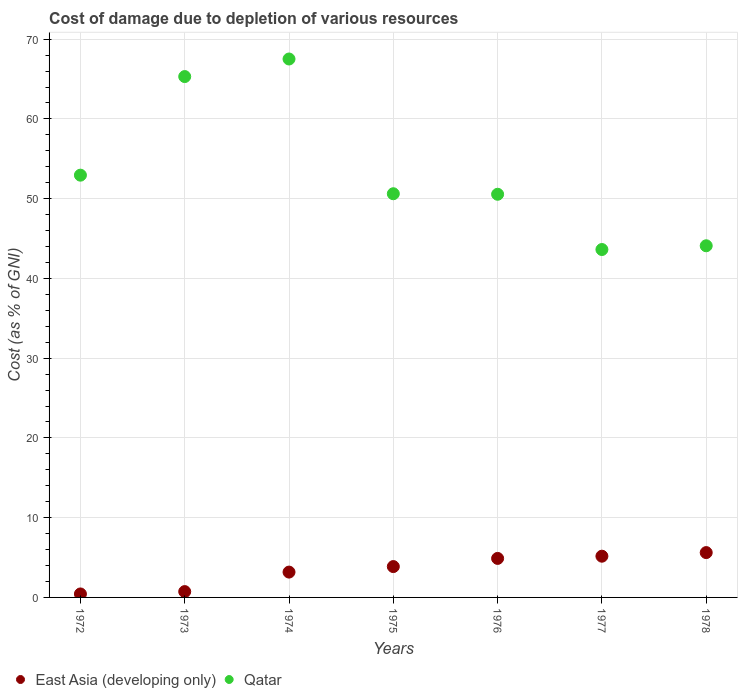How many different coloured dotlines are there?
Your answer should be very brief. 2. Is the number of dotlines equal to the number of legend labels?
Give a very brief answer. Yes. What is the cost of damage caused due to the depletion of various resources in Qatar in 1978?
Keep it short and to the point. 44.09. Across all years, what is the maximum cost of damage caused due to the depletion of various resources in East Asia (developing only)?
Provide a succinct answer. 5.62. Across all years, what is the minimum cost of damage caused due to the depletion of various resources in East Asia (developing only)?
Give a very brief answer. 0.44. In which year was the cost of damage caused due to the depletion of various resources in East Asia (developing only) maximum?
Offer a very short reply. 1978. In which year was the cost of damage caused due to the depletion of various resources in East Asia (developing only) minimum?
Give a very brief answer. 1972. What is the total cost of damage caused due to the depletion of various resources in East Asia (developing only) in the graph?
Provide a succinct answer. 23.9. What is the difference between the cost of damage caused due to the depletion of various resources in Qatar in 1974 and that in 1978?
Ensure brevity in your answer.  23.42. What is the difference between the cost of damage caused due to the depletion of various resources in Qatar in 1978 and the cost of damage caused due to the depletion of various resources in East Asia (developing only) in 1974?
Your answer should be very brief. 40.92. What is the average cost of damage caused due to the depletion of various resources in East Asia (developing only) per year?
Offer a terse response. 3.41. In the year 1974, what is the difference between the cost of damage caused due to the depletion of various resources in Qatar and cost of damage caused due to the depletion of various resources in East Asia (developing only)?
Offer a very short reply. 64.34. In how many years, is the cost of damage caused due to the depletion of various resources in Qatar greater than 48 %?
Make the answer very short. 5. What is the ratio of the cost of damage caused due to the depletion of various resources in Qatar in 1972 to that in 1978?
Provide a short and direct response. 1.2. Is the cost of damage caused due to the depletion of various resources in East Asia (developing only) in 1972 less than that in 1973?
Ensure brevity in your answer.  Yes. What is the difference between the highest and the second highest cost of damage caused due to the depletion of various resources in East Asia (developing only)?
Give a very brief answer. 0.45. What is the difference between the highest and the lowest cost of damage caused due to the depletion of various resources in East Asia (developing only)?
Make the answer very short. 5.19. In how many years, is the cost of damage caused due to the depletion of various resources in East Asia (developing only) greater than the average cost of damage caused due to the depletion of various resources in East Asia (developing only) taken over all years?
Provide a short and direct response. 4. Does the cost of damage caused due to the depletion of various resources in Qatar monotonically increase over the years?
Your answer should be compact. No. Is the cost of damage caused due to the depletion of various resources in Qatar strictly greater than the cost of damage caused due to the depletion of various resources in East Asia (developing only) over the years?
Make the answer very short. Yes. Are the values on the major ticks of Y-axis written in scientific E-notation?
Provide a short and direct response. No. Does the graph contain grids?
Give a very brief answer. Yes. How are the legend labels stacked?
Ensure brevity in your answer.  Horizontal. What is the title of the graph?
Provide a succinct answer. Cost of damage due to depletion of various resources. Does "Kyrgyz Republic" appear as one of the legend labels in the graph?
Provide a short and direct response. No. What is the label or title of the X-axis?
Your answer should be very brief. Years. What is the label or title of the Y-axis?
Provide a short and direct response. Cost (as % of GNI). What is the Cost (as % of GNI) of East Asia (developing only) in 1972?
Your answer should be very brief. 0.44. What is the Cost (as % of GNI) in Qatar in 1972?
Your response must be concise. 52.95. What is the Cost (as % of GNI) of East Asia (developing only) in 1973?
Offer a very short reply. 0.73. What is the Cost (as % of GNI) of Qatar in 1973?
Provide a succinct answer. 65.31. What is the Cost (as % of GNI) of East Asia (developing only) in 1974?
Ensure brevity in your answer.  3.18. What is the Cost (as % of GNI) in Qatar in 1974?
Your answer should be compact. 67.52. What is the Cost (as % of GNI) in East Asia (developing only) in 1975?
Ensure brevity in your answer.  3.87. What is the Cost (as % of GNI) of Qatar in 1975?
Provide a succinct answer. 50.62. What is the Cost (as % of GNI) of East Asia (developing only) in 1976?
Give a very brief answer. 4.89. What is the Cost (as % of GNI) of Qatar in 1976?
Provide a short and direct response. 50.55. What is the Cost (as % of GNI) in East Asia (developing only) in 1977?
Your response must be concise. 5.17. What is the Cost (as % of GNI) of Qatar in 1977?
Your response must be concise. 43.62. What is the Cost (as % of GNI) of East Asia (developing only) in 1978?
Offer a very short reply. 5.62. What is the Cost (as % of GNI) of Qatar in 1978?
Give a very brief answer. 44.09. Across all years, what is the maximum Cost (as % of GNI) in East Asia (developing only)?
Ensure brevity in your answer.  5.62. Across all years, what is the maximum Cost (as % of GNI) in Qatar?
Provide a short and direct response. 67.52. Across all years, what is the minimum Cost (as % of GNI) of East Asia (developing only)?
Your answer should be very brief. 0.44. Across all years, what is the minimum Cost (as % of GNI) in Qatar?
Provide a succinct answer. 43.62. What is the total Cost (as % of GNI) in East Asia (developing only) in the graph?
Provide a succinct answer. 23.9. What is the total Cost (as % of GNI) of Qatar in the graph?
Your response must be concise. 374.67. What is the difference between the Cost (as % of GNI) of East Asia (developing only) in 1972 and that in 1973?
Offer a terse response. -0.29. What is the difference between the Cost (as % of GNI) of Qatar in 1972 and that in 1973?
Ensure brevity in your answer.  -12.36. What is the difference between the Cost (as % of GNI) in East Asia (developing only) in 1972 and that in 1974?
Offer a very short reply. -2.74. What is the difference between the Cost (as % of GNI) of Qatar in 1972 and that in 1974?
Your answer should be very brief. -14.57. What is the difference between the Cost (as % of GNI) of East Asia (developing only) in 1972 and that in 1975?
Provide a succinct answer. -3.43. What is the difference between the Cost (as % of GNI) of Qatar in 1972 and that in 1975?
Ensure brevity in your answer.  2.33. What is the difference between the Cost (as % of GNI) in East Asia (developing only) in 1972 and that in 1976?
Offer a terse response. -4.46. What is the difference between the Cost (as % of GNI) of Qatar in 1972 and that in 1976?
Your response must be concise. 2.39. What is the difference between the Cost (as % of GNI) in East Asia (developing only) in 1972 and that in 1977?
Provide a short and direct response. -4.73. What is the difference between the Cost (as % of GNI) of Qatar in 1972 and that in 1977?
Your response must be concise. 9.32. What is the difference between the Cost (as % of GNI) of East Asia (developing only) in 1972 and that in 1978?
Ensure brevity in your answer.  -5.19. What is the difference between the Cost (as % of GNI) in Qatar in 1972 and that in 1978?
Your answer should be very brief. 8.85. What is the difference between the Cost (as % of GNI) of East Asia (developing only) in 1973 and that in 1974?
Ensure brevity in your answer.  -2.44. What is the difference between the Cost (as % of GNI) in Qatar in 1973 and that in 1974?
Keep it short and to the point. -2.2. What is the difference between the Cost (as % of GNI) in East Asia (developing only) in 1973 and that in 1975?
Your answer should be very brief. -3.14. What is the difference between the Cost (as % of GNI) in Qatar in 1973 and that in 1975?
Your response must be concise. 14.69. What is the difference between the Cost (as % of GNI) of East Asia (developing only) in 1973 and that in 1976?
Your answer should be compact. -4.16. What is the difference between the Cost (as % of GNI) in Qatar in 1973 and that in 1976?
Offer a very short reply. 14.76. What is the difference between the Cost (as % of GNI) of East Asia (developing only) in 1973 and that in 1977?
Offer a very short reply. -4.44. What is the difference between the Cost (as % of GNI) in Qatar in 1973 and that in 1977?
Ensure brevity in your answer.  21.69. What is the difference between the Cost (as % of GNI) in East Asia (developing only) in 1973 and that in 1978?
Your answer should be compact. -4.89. What is the difference between the Cost (as % of GNI) of Qatar in 1973 and that in 1978?
Offer a very short reply. 21.22. What is the difference between the Cost (as % of GNI) in East Asia (developing only) in 1974 and that in 1975?
Your answer should be very brief. -0.69. What is the difference between the Cost (as % of GNI) of Qatar in 1974 and that in 1975?
Ensure brevity in your answer.  16.9. What is the difference between the Cost (as % of GNI) of East Asia (developing only) in 1974 and that in 1976?
Provide a succinct answer. -1.72. What is the difference between the Cost (as % of GNI) in Qatar in 1974 and that in 1976?
Your answer should be very brief. 16.96. What is the difference between the Cost (as % of GNI) of East Asia (developing only) in 1974 and that in 1977?
Keep it short and to the point. -1.99. What is the difference between the Cost (as % of GNI) of Qatar in 1974 and that in 1977?
Offer a terse response. 23.89. What is the difference between the Cost (as % of GNI) in East Asia (developing only) in 1974 and that in 1978?
Make the answer very short. -2.45. What is the difference between the Cost (as % of GNI) of Qatar in 1974 and that in 1978?
Provide a succinct answer. 23.42. What is the difference between the Cost (as % of GNI) in East Asia (developing only) in 1975 and that in 1976?
Your answer should be compact. -1.02. What is the difference between the Cost (as % of GNI) of Qatar in 1975 and that in 1976?
Ensure brevity in your answer.  0.07. What is the difference between the Cost (as % of GNI) in East Asia (developing only) in 1975 and that in 1977?
Give a very brief answer. -1.3. What is the difference between the Cost (as % of GNI) of Qatar in 1975 and that in 1977?
Give a very brief answer. 6.99. What is the difference between the Cost (as % of GNI) in East Asia (developing only) in 1975 and that in 1978?
Keep it short and to the point. -1.75. What is the difference between the Cost (as % of GNI) in Qatar in 1975 and that in 1978?
Ensure brevity in your answer.  6.52. What is the difference between the Cost (as % of GNI) in East Asia (developing only) in 1976 and that in 1977?
Offer a very short reply. -0.28. What is the difference between the Cost (as % of GNI) of Qatar in 1976 and that in 1977?
Ensure brevity in your answer.  6.93. What is the difference between the Cost (as % of GNI) of East Asia (developing only) in 1976 and that in 1978?
Your answer should be very brief. -0.73. What is the difference between the Cost (as % of GNI) in Qatar in 1976 and that in 1978?
Offer a very short reply. 6.46. What is the difference between the Cost (as % of GNI) of East Asia (developing only) in 1977 and that in 1978?
Your answer should be compact. -0.45. What is the difference between the Cost (as % of GNI) of Qatar in 1977 and that in 1978?
Ensure brevity in your answer.  -0.47. What is the difference between the Cost (as % of GNI) in East Asia (developing only) in 1972 and the Cost (as % of GNI) in Qatar in 1973?
Offer a very short reply. -64.88. What is the difference between the Cost (as % of GNI) of East Asia (developing only) in 1972 and the Cost (as % of GNI) of Qatar in 1974?
Provide a succinct answer. -67.08. What is the difference between the Cost (as % of GNI) in East Asia (developing only) in 1972 and the Cost (as % of GNI) in Qatar in 1975?
Make the answer very short. -50.18. What is the difference between the Cost (as % of GNI) in East Asia (developing only) in 1972 and the Cost (as % of GNI) in Qatar in 1976?
Your answer should be compact. -50.12. What is the difference between the Cost (as % of GNI) in East Asia (developing only) in 1972 and the Cost (as % of GNI) in Qatar in 1977?
Make the answer very short. -43.19. What is the difference between the Cost (as % of GNI) in East Asia (developing only) in 1972 and the Cost (as % of GNI) in Qatar in 1978?
Your answer should be very brief. -43.66. What is the difference between the Cost (as % of GNI) in East Asia (developing only) in 1973 and the Cost (as % of GNI) in Qatar in 1974?
Provide a short and direct response. -66.78. What is the difference between the Cost (as % of GNI) in East Asia (developing only) in 1973 and the Cost (as % of GNI) in Qatar in 1975?
Your answer should be very brief. -49.89. What is the difference between the Cost (as % of GNI) in East Asia (developing only) in 1973 and the Cost (as % of GNI) in Qatar in 1976?
Offer a very short reply. -49.82. What is the difference between the Cost (as % of GNI) of East Asia (developing only) in 1973 and the Cost (as % of GNI) of Qatar in 1977?
Give a very brief answer. -42.89. What is the difference between the Cost (as % of GNI) in East Asia (developing only) in 1973 and the Cost (as % of GNI) in Qatar in 1978?
Ensure brevity in your answer.  -43.36. What is the difference between the Cost (as % of GNI) of East Asia (developing only) in 1974 and the Cost (as % of GNI) of Qatar in 1975?
Keep it short and to the point. -47.44. What is the difference between the Cost (as % of GNI) of East Asia (developing only) in 1974 and the Cost (as % of GNI) of Qatar in 1976?
Your answer should be compact. -47.38. What is the difference between the Cost (as % of GNI) of East Asia (developing only) in 1974 and the Cost (as % of GNI) of Qatar in 1977?
Provide a succinct answer. -40.45. What is the difference between the Cost (as % of GNI) of East Asia (developing only) in 1974 and the Cost (as % of GNI) of Qatar in 1978?
Ensure brevity in your answer.  -40.92. What is the difference between the Cost (as % of GNI) of East Asia (developing only) in 1975 and the Cost (as % of GNI) of Qatar in 1976?
Your answer should be very brief. -46.69. What is the difference between the Cost (as % of GNI) of East Asia (developing only) in 1975 and the Cost (as % of GNI) of Qatar in 1977?
Ensure brevity in your answer.  -39.76. What is the difference between the Cost (as % of GNI) of East Asia (developing only) in 1975 and the Cost (as % of GNI) of Qatar in 1978?
Ensure brevity in your answer.  -40.23. What is the difference between the Cost (as % of GNI) in East Asia (developing only) in 1976 and the Cost (as % of GNI) in Qatar in 1977?
Offer a terse response. -38.73. What is the difference between the Cost (as % of GNI) in East Asia (developing only) in 1976 and the Cost (as % of GNI) in Qatar in 1978?
Your answer should be compact. -39.2. What is the difference between the Cost (as % of GNI) of East Asia (developing only) in 1977 and the Cost (as % of GNI) of Qatar in 1978?
Provide a short and direct response. -38.92. What is the average Cost (as % of GNI) of East Asia (developing only) per year?
Offer a very short reply. 3.41. What is the average Cost (as % of GNI) in Qatar per year?
Give a very brief answer. 53.52. In the year 1972, what is the difference between the Cost (as % of GNI) of East Asia (developing only) and Cost (as % of GNI) of Qatar?
Give a very brief answer. -52.51. In the year 1973, what is the difference between the Cost (as % of GNI) in East Asia (developing only) and Cost (as % of GNI) in Qatar?
Ensure brevity in your answer.  -64.58. In the year 1974, what is the difference between the Cost (as % of GNI) of East Asia (developing only) and Cost (as % of GNI) of Qatar?
Offer a terse response. -64.34. In the year 1975, what is the difference between the Cost (as % of GNI) of East Asia (developing only) and Cost (as % of GNI) of Qatar?
Offer a very short reply. -46.75. In the year 1976, what is the difference between the Cost (as % of GNI) of East Asia (developing only) and Cost (as % of GNI) of Qatar?
Give a very brief answer. -45.66. In the year 1977, what is the difference between the Cost (as % of GNI) of East Asia (developing only) and Cost (as % of GNI) of Qatar?
Give a very brief answer. -38.45. In the year 1978, what is the difference between the Cost (as % of GNI) in East Asia (developing only) and Cost (as % of GNI) in Qatar?
Your answer should be very brief. -38.47. What is the ratio of the Cost (as % of GNI) of East Asia (developing only) in 1972 to that in 1973?
Give a very brief answer. 0.6. What is the ratio of the Cost (as % of GNI) in Qatar in 1972 to that in 1973?
Your response must be concise. 0.81. What is the ratio of the Cost (as % of GNI) in East Asia (developing only) in 1972 to that in 1974?
Your answer should be compact. 0.14. What is the ratio of the Cost (as % of GNI) of Qatar in 1972 to that in 1974?
Give a very brief answer. 0.78. What is the ratio of the Cost (as % of GNI) in East Asia (developing only) in 1972 to that in 1975?
Keep it short and to the point. 0.11. What is the ratio of the Cost (as % of GNI) of Qatar in 1972 to that in 1975?
Offer a very short reply. 1.05. What is the ratio of the Cost (as % of GNI) of East Asia (developing only) in 1972 to that in 1976?
Offer a very short reply. 0.09. What is the ratio of the Cost (as % of GNI) in Qatar in 1972 to that in 1976?
Give a very brief answer. 1.05. What is the ratio of the Cost (as % of GNI) of East Asia (developing only) in 1972 to that in 1977?
Provide a succinct answer. 0.08. What is the ratio of the Cost (as % of GNI) of Qatar in 1972 to that in 1977?
Keep it short and to the point. 1.21. What is the ratio of the Cost (as % of GNI) in East Asia (developing only) in 1972 to that in 1978?
Your answer should be very brief. 0.08. What is the ratio of the Cost (as % of GNI) of Qatar in 1972 to that in 1978?
Provide a succinct answer. 1.2. What is the ratio of the Cost (as % of GNI) of East Asia (developing only) in 1973 to that in 1974?
Make the answer very short. 0.23. What is the ratio of the Cost (as % of GNI) of Qatar in 1973 to that in 1974?
Your answer should be compact. 0.97. What is the ratio of the Cost (as % of GNI) in East Asia (developing only) in 1973 to that in 1975?
Your response must be concise. 0.19. What is the ratio of the Cost (as % of GNI) in Qatar in 1973 to that in 1975?
Give a very brief answer. 1.29. What is the ratio of the Cost (as % of GNI) of East Asia (developing only) in 1973 to that in 1976?
Provide a succinct answer. 0.15. What is the ratio of the Cost (as % of GNI) in Qatar in 1973 to that in 1976?
Give a very brief answer. 1.29. What is the ratio of the Cost (as % of GNI) of East Asia (developing only) in 1973 to that in 1977?
Provide a short and direct response. 0.14. What is the ratio of the Cost (as % of GNI) of Qatar in 1973 to that in 1977?
Your response must be concise. 1.5. What is the ratio of the Cost (as % of GNI) of East Asia (developing only) in 1973 to that in 1978?
Provide a short and direct response. 0.13. What is the ratio of the Cost (as % of GNI) of Qatar in 1973 to that in 1978?
Offer a very short reply. 1.48. What is the ratio of the Cost (as % of GNI) in East Asia (developing only) in 1974 to that in 1975?
Your response must be concise. 0.82. What is the ratio of the Cost (as % of GNI) in Qatar in 1974 to that in 1975?
Give a very brief answer. 1.33. What is the ratio of the Cost (as % of GNI) in East Asia (developing only) in 1974 to that in 1976?
Your response must be concise. 0.65. What is the ratio of the Cost (as % of GNI) in Qatar in 1974 to that in 1976?
Keep it short and to the point. 1.34. What is the ratio of the Cost (as % of GNI) in East Asia (developing only) in 1974 to that in 1977?
Keep it short and to the point. 0.61. What is the ratio of the Cost (as % of GNI) of Qatar in 1974 to that in 1977?
Your answer should be very brief. 1.55. What is the ratio of the Cost (as % of GNI) of East Asia (developing only) in 1974 to that in 1978?
Offer a terse response. 0.56. What is the ratio of the Cost (as % of GNI) of Qatar in 1974 to that in 1978?
Offer a terse response. 1.53. What is the ratio of the Cost (as % of GNI) in East Asia (developing only) in 1975 to that in 1976?
Your answer should be compact. 0.79. What is the ratio of the Cost (as % of GNI) in East Asia (developing only) in 1975 to that in 1977?
Keep it short and to the point. 0.75. What is the ratio of the Cost (as % of GNI) in Qatar in 1975 to that in 1977?
Your answer should be compact. 1.16. What is the ratio of the Cost (as % of GNI) of East Asia (developing only) in 1975 to that in 1978?
Ensure brevity in your answer.  0.69. What is the ratio of the Cost (as % of GNI) of Qatar in 1975 to that in 1978?
Offer a very short reply. 1.15. What is the ratio of the Cost (as % of GNI) in East Asia (developing only) in 1976 to that in 1977?
Make the answer very short. 0.95. What is the ratio of the Cost (as % of GNI) in Qatar in 1976 to that in 1977?
Offer a terse response. 1.16. What is the ratio of the Cost (as % of GNI) of East Asia (developing only) in 1976 to that in 1978?
Give a very brief answer. 0.87. What is the ratio of the Cost (as % of GNI) in Qatar in 1976 to that in 1978?
Keep it short and to the point. 1.15. What is the ratio of the Cost (as % of GNI) in East Asia (developing only) in 1977 to that in 1978?
Keep it short and to the point. 0.92. What is the ratio of the Cost (as % of GNI) in Qatar in 1977 to that in 1978?
Make the answer very short. 0.99. What is the difference between the highest and the second highest Cost (as % of GNI) of East Asia (developing only)?
Give a very brief answer. 0.45. What is the difference between the highest and the second highest Cost (as % of GNI) of Qatar?
Keep it short and to the point. 2.2. What is the difference between the highest and the lowest Cost (as % of GNI) in East Asia (developing only)?
Provide a short and direct response. 5.19. What is the difference between the highest and the lowest Cost (as % of GNI) in Qatar?
Provide a succinct answer. 23.89. 